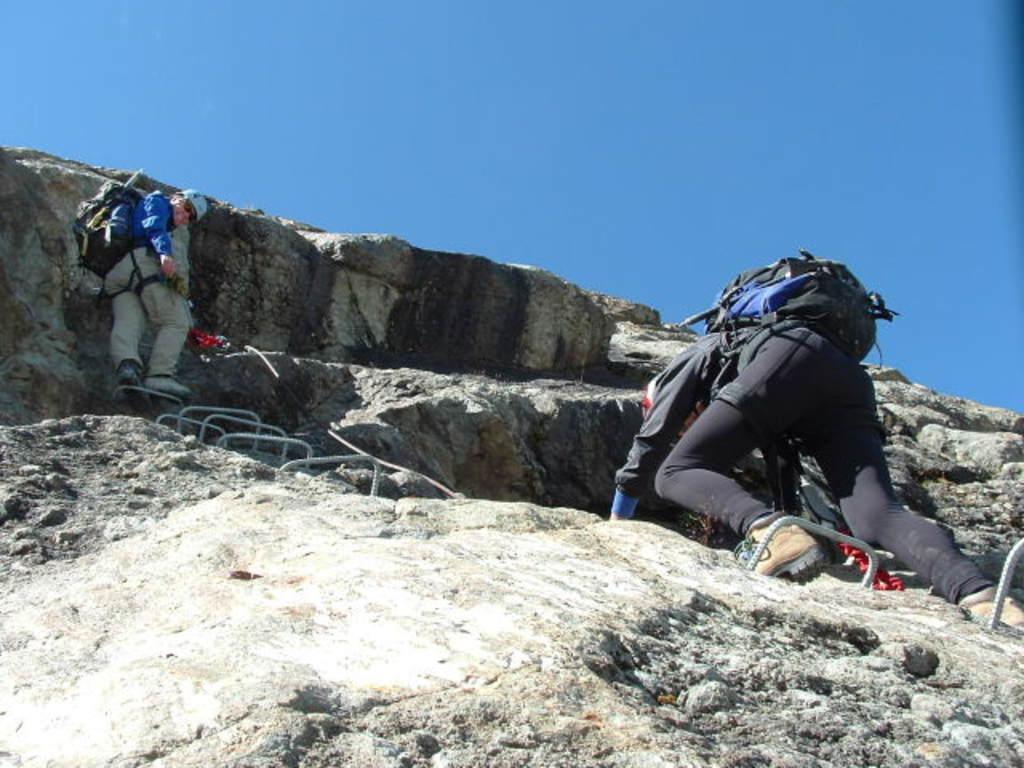Please provide a concise description of this image. In this image, we can see people wearing bags and caps and here we can see rods and there are rocks. At the top, there is sky. 